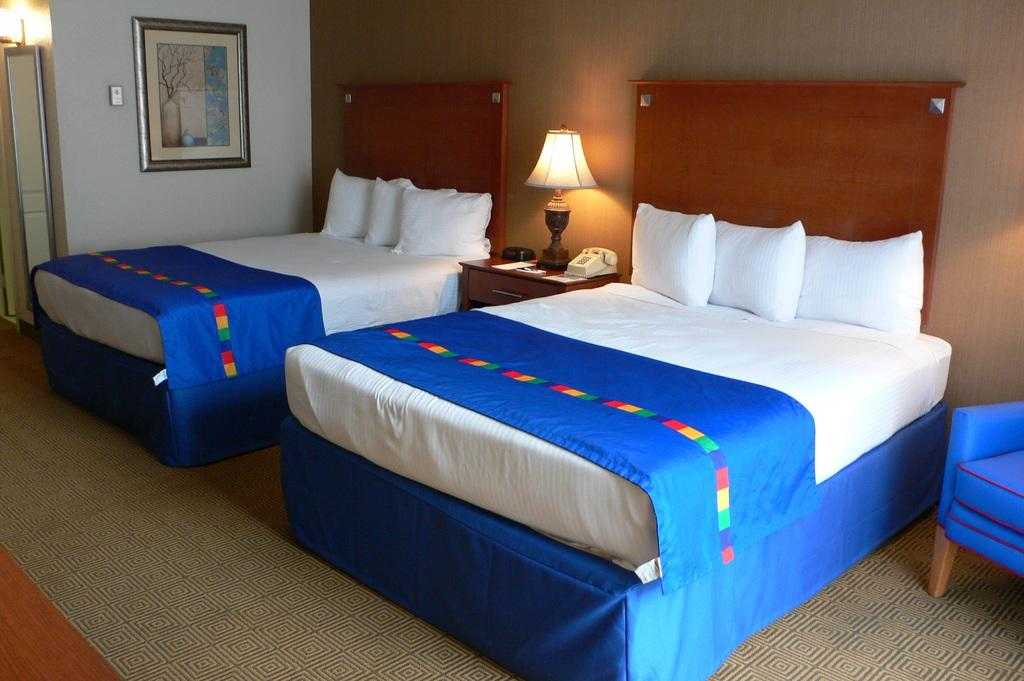How many beds are visible in the image? There are two beds in the image. What is located between the two beds? There is a lamp in between the two beds. Where are the beds and lamp situated? The beds and lamp are in a room. Can you see any scissors on the beds or near the lamp in the image? There is no mention of scissors in the image, so it cannot be determined if any are present. Is there any liquid visible in the image? There is no mention of any liquid in the image. Can you see a lake in the image? There is no mention of a lake in the image. 